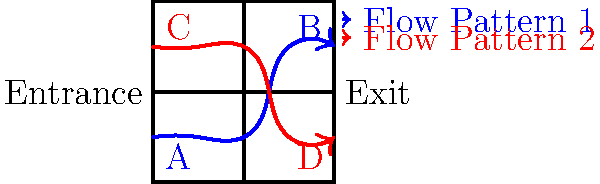Based on the museum floor plan and visitor flow patterns shown, which machine learning algorithm would be most suitable for predicting future visitor movements and potentially identifying bottlenecks? To answer this question, let's consider the characteristics of the problem and the available data:

1. The data represents sequential movements of visitors through the museum.
2. There are clear patterns in the flow, as shown by the blue and red paths.
3. The goal is to predict future movements and identify potential bottlenecks.

Given these factors, we can deduce that:

1. This is a sequential data problem, where the next position depends on previous positions.
2. There are multiple possible paths through the museum, indicating a probabilistic nature to the movements.
3. We need to capture both the sequence of movements and the likelihood of different paths.

The most suitable algorithm for this type of problem is a Hidden Markov Model (HMM) because:

1. HMMs are designed to work with sequential data.
2. They can model the probability of transitioning from one state (location) to another.
3. HMMs can handle partially observable states, which is useful if we don't have complete information about visitor locations at all times.
4. They can be used to predict future states (locations) based on observed sequences.
5. HMMs can identify likely sequences of states, which could help in identifying potential bottlenecks.

Other algorithms like Recurrent Neural Networks (RNNs) or Long Short-Term Memory (LSTM) networks could also be considered, but HMMs are particularly well-suited for this type of sequential, probabilistic data with a relatively small number of discrete states.
Answer: Hidden Markov Model (HMM) 